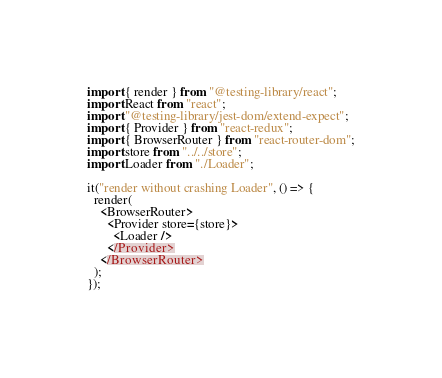<code> <loc_0><loc_0><loc_500><loc_500><_TypeScript_>import { render } from "@testing-library/react";
import React from "react";
import "@testing-library/jest-dom/extend-expect";
import { Provider } from "react-redux";
import { BrowserRouter } from "react-router-dom";
import store from "../../store";
import Loader from "./Loader";

it("render without crashing Loader", () => {
  render(
    <BrowserRouter>
      <Provider store={store}>
        <Loader />
      </Provider>
    </BrowserRouter>
  );
});
</code> 